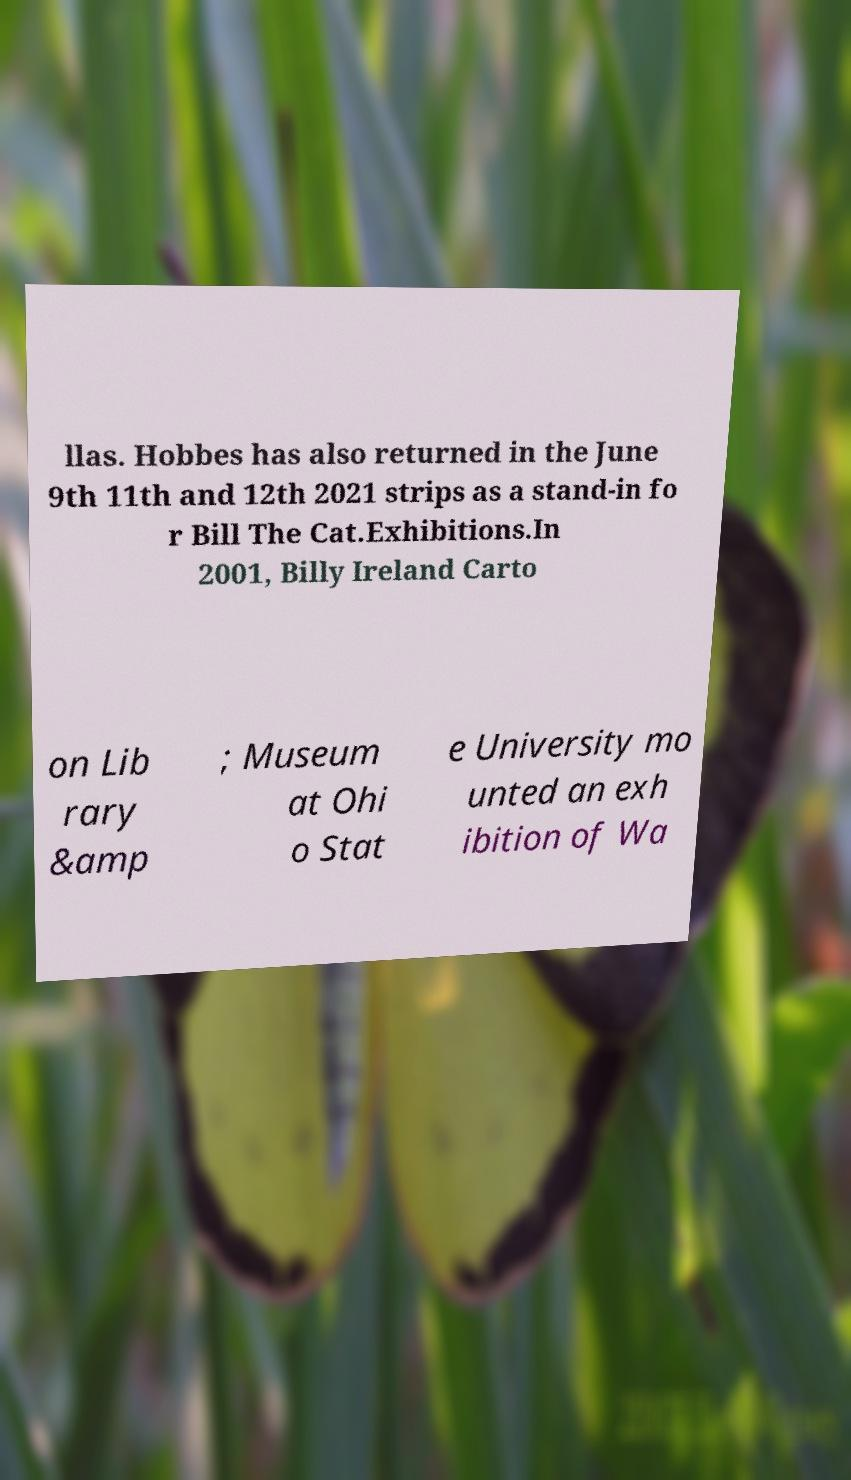Can you accurately transcribe the text from the provided image for me? llas. Hobbes has also returned in the June 9th 11th and 12th 2021 strips as a stand-in fo r Bill The Cat.Exhibitions.In 2001, Billy Ireland Carto on Lib rary &amp ; Museum at Ohi o Stat e University mo unted an exh ibition of Wa 